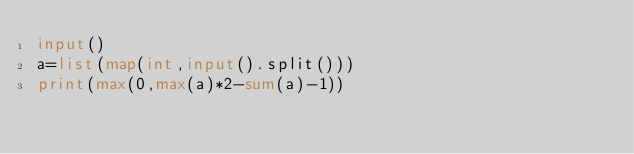<code> <loc_0><loc_0><loc_500><loc_500><_Python_>input()
a=list(map(int,input().split()))
print(max(0,max(a)*2-sum(a)-1))</code> 